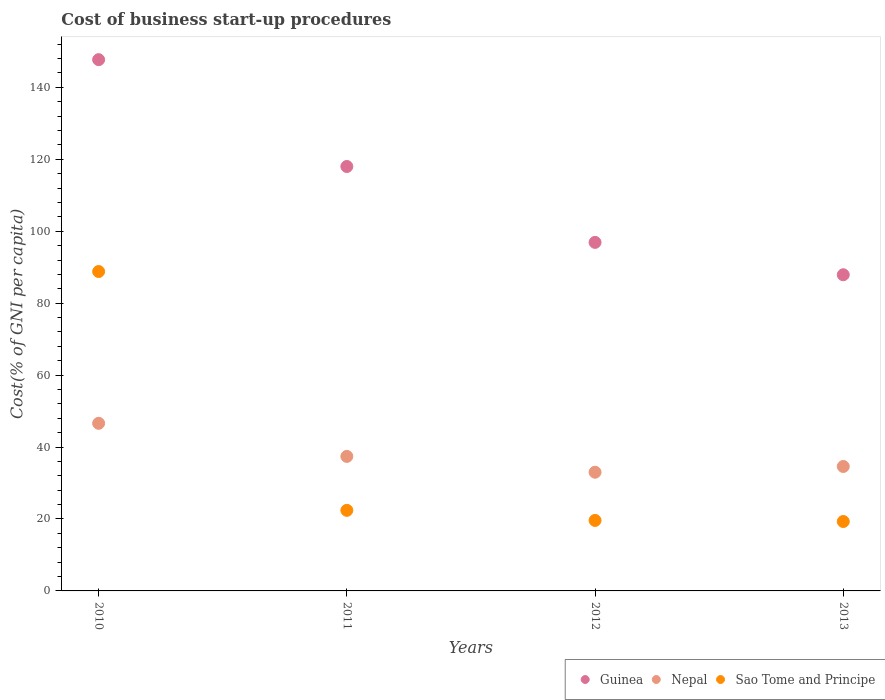How many different coloured dotlines are there?
Provide a short and direct response. 3. Is the number of dotlines equal to the number of legend labels?
Your response must be concise. Yes. What is the cost of business start-up procedures in Sao Tome and Principe in 2013?
Your response must be concise. 19.3. Across all years, what is the maximum cost of business start-up procedures in Sao Tome and Principe?
Provide a succinct answer. 88.8. Across all years, what is the minimum cost of business start-up procedures in Guinea?
Provide a succinct answer. 87.9. In which year was the cost of business start-up procedures in Sao Tome and Principe maximum?
Keep it short and to the point. 2010. What is the total cost of business start-up procedures in Guinea in the graph?
Ensure brevity in your answer.  450.5. What is the difference between the cost of business start-up procedures in Nepal in 2010 and that in 2012?
Ensure brevity in your answer.  13.6. What is the difference between the cost of business start-up procedures in Guinea in 2013 and the cost of business start-up procedures in Sao Tome and Principe in 2012?
Provide a short and direct response. 68.3. What is the average cost of business start-up procedures in Guinea per year?
Ensure brevity in your answer.  112.62. In the year 2013, what is the difference between the cost of business start-up procedures in Guinea and cost of business start-up procedures in Sao Tome and Principe?
Ensure brevity in your answer.  68.6. What is the ratio of the cost of business start-up procedures in Guinea in 2010 to that in 2012?
Your answer should be compact. 1.52. Is the cost of business start-up procedures in Sao Tome and Principe in 2011 less than that in 2012?
Provide a succinct answer. No. Is the difference between the cost of business start-up procedures in Guinea in 2011 and 2013 greater than the difference between the cost of business start-up procedures in Sao Tome and Principe in 2011 and 2013?
Provide a short and direct response. Yes. What is the difference between the highest and the second highest cost of business start-up procedures in Sao Tome and Principe?
Your answer should be compact. 66.4. What is the difference between the highest and the lowest cost of business start-up procedures in Nepal?
Provide a short and direct response. 13.6. In how many years, is the cost of business start-up procedures in Nepal greater than the average cost of business start-up procedures in Nepal taken over all years?
Your answer should be compact. 1. Is the sum of the cost of business start-up procedures in Sao Tome and Principe in 2010 and 2011 greater than the maximum cost of business start-up procedures in Guinea across all years?
Your response must be concise. No. Is the cost of business start-up procedures in Nepal strictly less than the cost of business start-up procedures in Guinea over the years?
Keep it short and to the point. Yes. How many dotlines are there?
Offer a terse response. 3. What is the difference between two consecutive major ticks on the Y-axis?
Ensure brevity in your answer.  20. Are the values on the major ticks of Y-axis written in scientific E-notation?
Keep it short and to the point. No. Where does the legend appear in the graph?
Ensure brevity in your answer.  Bottom right. How many legend labels are there?
Provide a succinct answer. 3. How are the legend labels stacked?
Offer a terse response. Horizontal. What is the title of the graph?
Your response must be concise. Cost of business start-up procedures. What is the label or title of the Y-axis?
Your response must be concise. Cost(% of GNI per capita). What is the Cost(% of GNI per capita) of Guinea in 2010?
Your answer should be very brief. 147.7. What is the Cost(% of GNI per capita) of Nepal in 2010?
Make the answer very short. 46.6. What is the Cost(% of GNI per capita) in Sao Tome and Principe in 2010?
Provide a succinct answer. 88.8. What is the Cost(% of GNI per capita) of Guinea in 2011?
Keep it short and to the point. 118. What is the Cost(% of GNI per capita) in Nepal in 2011?
Give a very brief answer. 37.4. What is the Cost(% of GNI per capita) in Sao Tome and Principe in 2011?
Make the answer very short. 22.4. What is the Cost(% of GNI per capita) of Guinea in 2012?
Ensure brevity in your answer.  96.9. What is the Cost(% of GNI per capita) of Sao Tome and Principe in 2012?
Make the answer very short. 19.6. What is the Cost(% of GNI per capita) of Guinea in 2013?
Your answer should be compact. 87.9. What is the Cost(% of GNI per capita) of Nepal in 2013?
Your answer should be very brief. 34.6. What is the Cost(% of GNI per capita) of Sao Tome and Principe in 2013?
Offer a terse response. 19.3. Across all years, what is the maximum Cost(% of GNI per capita) in Guinea?
Keep it short and to the point. 147.7. Across all years, what is the maximum Cost(% of GNI per capita) in Nepal?
Keep it short and to the point. 46.6. Across all years, what is the maximum Cost(% of GNI per capita) of Sao Tome and Principe?
Provide a succinct answer. 88.8. Across all years, what is the minimum Cost(% of GNI per capita) in Guinea?
Your answer should be compact. 87.9. Across all years, what is the minimum Cost(% of GNI per capita) of Nepal?
Provide a succinct answer. 33. Across all years, what is the minimum Cost(% of GNI per capita) of Sao Tome and Principe?
Make the answer very short. 19.3. What is the total Cost(% of GNI per capita) in Guinea in the graph?
Make the answer very short. 450.5. What is the total Cost(% of GNI per capita) of Nepal in the graph?
Keep it short and to the point. 151.6. What is the total Cost(% of GNI per capita) in Sao Tome and Principe in the graph?
Offer a terse response. 150.1. What is the difference between the Cost(% of GNI per capita) in Guinea in 2010 and that in 2011?
Your response must be concise. 29.7. What is the difference between the Cost(% of GNI per capita) in Sao Tome and Principe in 2010 and that in 2011?
Your answer should be very brief. 66.4. What is the difference between the Cost(% of GNI per capita) of Guinea in 2010 and that in 2012?
Your answer should be compact. 50.8. What is the difference between the Cost(% of GNI per capita) in Sao Tome and Principe in 2010 and that in 2012?
Keep it short and to the point. 69.2. What is the difference between the Cost(% of GNI per capita) in Guinea in 2010 and that in 2013?
Keep it short and to the point. 59.8. What is the difference between the Cost(% of GNI per capita) of Nepal in 2010 and that in 2013?
Ensure brevity in your answer.  12. What is the difference between the Cost(% of GNI per capita) in Sao Tome and Principe in 2010 and that in 2013?
Your answer should be compact. 69.5. What is the difference between the Cost(% of GNI per capita) of Guinea in 2011 and that in 2012?
Make the answer very short. 21.1. What is the difference between the Cost(% of GNI per capita) of Sao Tome and Principe in 2011 and that in 2012?
Offer a very short reply. 2.8. What is the difference between the Cost(% of GNI per capita) in Guinea in 2011 and that in 2013?
Make the answer very short. 30.1. What is the difference between the Cost(% of GNI per capita) of Nepal in 2011 and that in 2013?
Provide a succinct answer. 2.8. What is the difference between the Cost(% of GNI per capita) in Guinea in 2012 and that in 2013?
Give a very brief answer. 9. What is the difference between the Cost(% of GNI per capita) in Guinea in 2010 and the Cost(% of GNI per capita) in Nepal in 2011?
Your response must be concise. 110.3. What is the difference between the Cost(% of GNI per capita) of Guinea in 2010 and the Cost(% of GNI per capita) of Sao Tome and Principe in 2011?
Your answer should be very brief. 125.3. What is the difference between the Cost(% of GNI per capita) of Nepal in 2010 and the Cost(% of GNI per capita) of Sao Tome and Principe in 2011?
Your answer should be very brief. 24.2. What is the difference between the Cost(% of GNI per capita) in Guinea in 2010 and the Cost(% of GNI per capita) in Nepal in 2012?
Ensure brevity in your answer.  114.7. What is the difference between the Cost(% of GNI per capita) in Guinea in 2010 and the Cost(% of GNI per capita) in Sao Tome and Principe in 2012?
Make the answer very short. 128.1. What is the difference between the Cost(% of GNI per capita) in Guinea in 2010 and the Cost(% of GNI per capita) in Nepal in 2013?
Keep it short and to the point. 113.1. What is the difference between the Cost(% of GNI per capita) in Guinea in 2010 and the Cost(% of GNI per capita) in Sao Tome and Principe in 2013?
Make the answer very short. 128.4. What is the difference between the Cost(% of GNI per capita) in Nepal in 2010 and the Cost(% of GNI per capita) in Sao Tome and Principe in 2013?
Give a very brief answer. 27.3. What is the difference between the Cost(% of GNI per capita) in Guinea in 2011 and the Cost(% of GNI per capita) in Nepal in 2012?
Your response must be concise. 85. What is the difference between the Cost(% of GNI per capita) in Guinea in 2011 and the Cost(% of GNI per capita) in Sao Tome and Principe in 2012?
Your answer should be compact. 98.4. What is the difference between the Cost(% of GNI per capita) of Nepal in 2011 and the Cost(% of GNI per capita) of Sao Tome and Principe in 2012?
Keep it short and to the point. 17.8. What is the difference between the Cost(% of GNI per capita) of Guinea in 2011 and the Cost(% of GNI per capita) of Nepal in 2013?
Give a very brief answer. 83.4. What is the difference between the Cost(% of GNI per capita) in Guinea in 2011 and the Cost(% of GNI per capita) in Sao Tome and Principe in 2013?
Your answer should be very brief. 98.7. What is the difference between the Cost(% of GNI per capita) in Guinea in 2012 and the Cost(% of GNI per capita) in Nepal in 2013?
Make the answer very short. 62.3. What is the difference between the Cost(% of GNI per capita) of Guinea in 2012 and the Cost(% of GNI per capita) of Sao Tome and Principe in 2013?
Provide a short and direct response. 77.6. What is the difference between the Cost(% of GNI per capita) in Nepal in 2012 and the Cost(% of GNI per capita) in Sao Tome and Principe in 2013?
Your answer should be very brief. 13.7. What is the average Cost(% of GNI per capita) in Guinea per year?
Offer a very short reply. 112.62. What is the average Cost(% of GNI per capita) in Nepal per year?
Give a very brief answer. 37.9. What is the average Cost(% of GNI per capita) in Sao Tome and Principe per year?
Your response must be concise. 37.52. In the year 2010, what is the difference between the Cost(% of GNI per capita) in Guinea and Cost(% of GNI per capita) in Nepal?
Make the answer very short. 101.1. In the year 2010, what is the difference between the Cost(% of GNI per capita) in Guinea and Cost(% of GNI per capita) in Sao Tome and Principe?
Keep it short and to the point. 58.9. In the year 2010, what is the difference between the Cost(% of GNI per capita) of Nepal and Cost(% of GNI per capita) of Sao Tome and Principe?
Your answer should be compact. -42.2. In the year 2011, what is the difference between the Cost(% of GNI per capita) of Guinea and Cost(% of GNI per capita) of Nepal?
Keep it short and to the point. 80.6. In the year 2011, what is the difference between the Cost(% of GNI per capita) in Guinea and Cost(% of GNI per capita) in Sao Tome and Principe?
Provide a short and direct response. 95.6. In the year 2011, what is the difference between the Cost(% of GNI per capita) in Nepal and Cost(% of GNI per capita) in Sao Tome and Principe?
Ensure brevity in your answer.  15. In the year 2012, what is the difference between the Cost(% of GNI per capita) in Guinea and Cost(% of GNI per capita) in Nepal?
Your answer should be compact. 63.9. In the year 2012, what is the difference between the Cost(% of GNI per capita) in Guinea and Cost(% of GNI per capita) in Sao Tome and Principe?
Your answer should be very brief. 77.3. In the year 2013, what is the difference between the Cost(% of GNI per capita) of Guinea and Cost(% of GNI per capita) of Nepal?
Give a very brief answer. 53.3. In the year 2013, what is the difference between the Cost(% of GNI per capita) in Guinea and Cost(% of GNI per capita) in Sao Tome and Principe?
Your answer should be compact. 68.6. In the year 2013, what is the difference between the Cost(% of GNI per capita) of Nepal and Cost(% of GNI per capita) of Sao Tome and Principe?
Provide a short and direct response. 15.3. What is the ratio of the Cost(% of GNI per capita) in Guinea in 2010 to that in 2011?
Make the answer very short. 1.25. What is the ratio of the Cost(% of GNI per capita) of Nepal in 2010 to that in 2011?
Give a very brief answer. 1.25. What is the ratio of the Cost(% of GNI per capita) in Sao Tome and Principe in 2010 to that in 2011?
Provide a short and direct response. 3.96. What is the ratio of the Cost(% of GNI per capita) in Guinea in 2010 to that in 2012?
Provide a short and direct response. 1.52. What is the ratio of the Cost(% of GNI per capita) in Nepal in 2010 to that in 2012?
Your response must be concise. 1.41. What is the ratio of the Cost(% of GNI per capita) of Sao Tome and Principe in 2010 to that in 2012?
Provide a short and direct response. 4.53. What is the ratio of the Cost(% of GNI per capita) of Guinea in 2010 to that in 2013?
Offer a very short reply. 1.68. What is the ratio of the Cost(% of GNI per capita) of Nepal in 2010 to that in 2013?
Ensure brevity in your answer.  1.35. What is the ratio of the Cost(% of GNI per capita) in Sao Tome and Principe in 2010 to that in 2013?
Provide a short and direct response. 4.6. What is the ratio of the Cost(% of GNI per capita) in Guinea in 2011 to that in 2012?
Offer a terse response. 1.22. What is the ratio of the Cost(% of GNI per capita) in Nepal in 2011 to that in 2012?
Offer a very short reply. 1.13. What is the ratio of the Cost(% of GNI per capita) of Sao Tome and Principe in 2011 to that in 2012?
Offer a very short reply. 1.14. What is the ratio of the Cost(% of GNI per capita) in Guinea in 2011 to that in 2013?
Offer a terse response. 1.34. What is the ratio of the Cost(% of GNI per capita) in Nepal in 2011 to that in 2013?
Give a very brief answer. 1.08. What is the ratio of the Cost(% of GNI per capita) of Sao Tome and Principe in 2011 to that in 2013?
Keep it short and to the point. 1.16. What is the ratio of the Cost(% of GNI per capita) of Guinea in 2012 to that in 2013?
Provide a succinct answer. 1.1. What is the ratio of the Cost(% of GNI per capita) in Nepal in 2012 to that in 2013?
Ensure brevity in your answer.  0.95. What is the ratio of the Cost(% of GNI per capita) of Sao Tome and Principe in 2012 to that in 2013?
Your response must be concise. 1.02. What is the difference between the highest and the second highest Cost(% of GNI per capita) in Guinea?
Give a very brief answer. 29.7. What is the difference between the highest and the second highest Cost(% of GNI per capita) in Nepal?
Give a very brief answer. 9.2. What is the difference between the highest and the second highest Cost(% of GNI per capita) in Sao Tome and Principe?
Your response must be concise. 66.4. What is the difference between the highest and the lowest Cost(% of GNI per capita) in Guinea?
Make the answer very short. 59.8. What is the difference between the highest and the lowest Cost(% of GNI per capita) of Nepal?
Provide a succinct answer. 13.6. What is the difference between the highest and the lowest Cost(% of GNI per capita) in Sao Tome and Principe?
Provide a succinct answer. 69.5. 